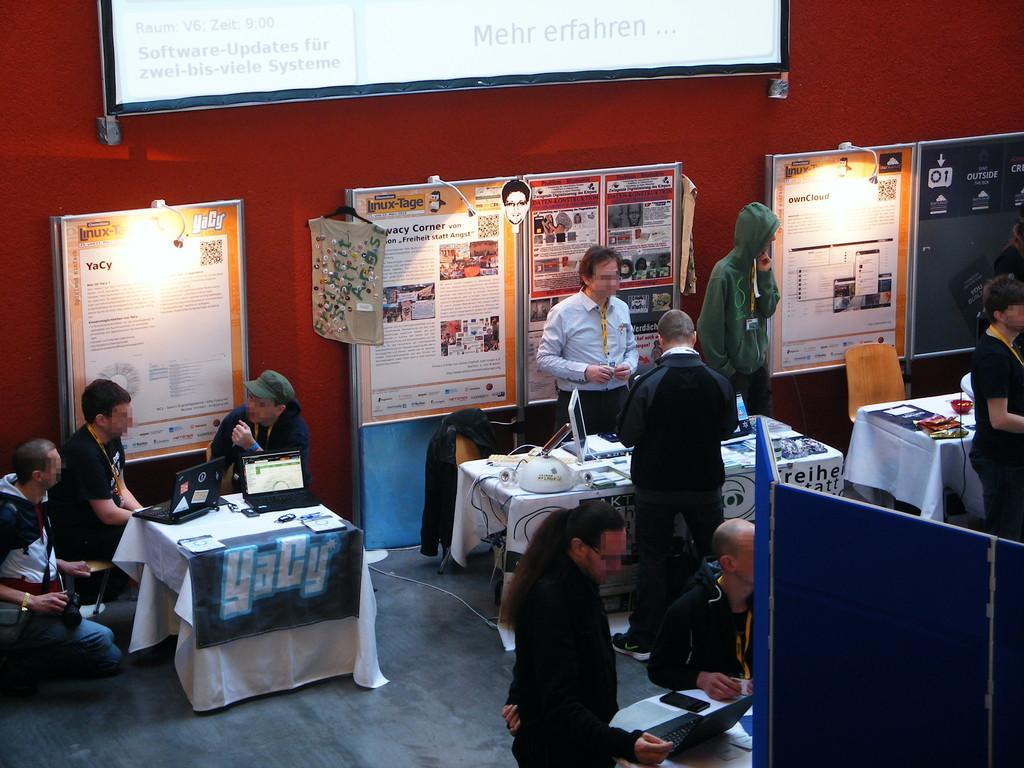How would you summarize this image in a sentence or two? In this image we can see a group of people. We can also see some tables containing the laptops and some objects on them. We can also see some boards and a display screen on a wall with some text on them. In the foreground we can see a divider. 